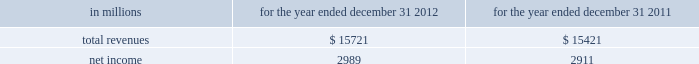See note 10 goodwill and other intangible assets for further discussion of the accounting for goodwill and other intangible assets .
The estimated amount of rbc bank ( usa ) revenue and net income ( excluding integration costs ) included in pnc 2019s consolidated income statement for 2012 was $ 1.0 billion and $ 273 million , respectively .
Upon closing and conversion of the rbc bank ( usa ) transaction , subsequent to march 2 , 2012 , separate records for rbc bank ( usa ) as a stand-alone business have not been maintained as the operations of rbc bank ( usa ) have been fully integrated into pnc .
Rbc bank ( usa ) revenue and earnings disclosed above reflect management 2019s best estimate , based on information available at the reporting date .
The table presents certain unaudited pro forma information for illustrative purposes only , for 2012 and 2011 as if rbc bank ( usa ) had been acquired on january 1 , 2011 .
The unaudited estimated pro forma information combines the historical results of rbc bank ( usa ) with the company 2019s consolidated historical results and includes certain adjustments reflecting the estimated impact of certain fair value adjustments for the respective periods .
The pro forma information is not indicative of what would have occurred had the acquisition taken place on january 1 , 2011 .
In particular , no adjustments have been made to eliminate the impact of other-than-temporary impairment losses and losses recognized on the sale of securities that may not have been necessary had the investment securities been recorded at fair value as of january 1 , 2011 .
The unaudited pro forma information does not consider any changes to the provision for credit losses resulting from recording loan assets at fair value .
Additionally , the pro forma financial information does not include the impact of possible business model changes and does not reflect pro forma adjustments to conform accounting policies between rbc bank ( usa ) and pnc .
Additionally , pnc expects to achieve further operating cost savings and other business synergies , including revenue growth , as a result of the acquisition that are not reflected in the pro forma amounts that follow .
As a result , actual results will differ from the unaudited pro forma information presented .
Table 57 : rbc bank ( usa ) and pnc unaudited pro forma results .
In connection with the rbc bank ( usa ) acquisition and other prior acquisitions , pnc recognized $ 267 million of integration charges in 2012 .
Pnc recognized $ 42 million of integration charges in 2011 in connection with prior acquisitions .
The integration charges are included in the table above .
Sale of smartstreet effective october 26 , 2012 , pnc divested certain deposits and assets of the smartstreet business unit , which was acquired by pnc as part of the rbc bank ( usa ) acquisition , to union bank , n.a .
Smartstreet is a nationwide business focused on homeowner or community association managers and had approximately $ 1 billion of assets and deposits as of september 30 , 2012 .
The gain on sale was immaterial and resulted in a reduction of goodwill and core deposit intangibles of $ 46 million and $ 13 million , respectively .
Results from operations of smartstreet from march 2 , 2012 through october 26 , 2012 are included in our consolidated income statement .
Flagstar branch acquisition effective december 9 , 2011 , pnc acquired 27 branches in the northern metropolitan atlanta , georgia area from flagstar bank , fsb , a subsidiary of flagstar bancorp , inc .
The fair value of the assets acquired totaled approximately $ 211.8 million , including $ 169.3 million in cash , $ 24.3 million in fixed assets and $ 18.2 million of goodwill and intangible assets .
We also assumed approximately $ 210.5 million of deposits associated with these branches .
No deposit premium was paid and no loans were acquired in the transaction .
Our consolidated income statement includes the impact of the branch activity subsequent to our december 9 , 2011 acquisition .
Bankatlantic branch acquisition effective june 6 , 2011 , we acquired 19 branches in the greater tampa , florida area from bankatlantic , a subsidiary of bankatlantic bancorp , inc .
The fair value of the assets acquired totaled $ 324.9 million , including $ 256.9 million in cash , $ 26.0 million in fixed assets and $ 42.0 million of goodwill and intangible assets .
We also assumed approximately $ 324.5 million of deposits associated with these branches .
A $ 39.0 million deposit premium was paid and no loans were acquired in the transaction .
Our consolidated income statement includes the impact of the branch activity subsequent to our june 6 , 2011 acquisition .
Sale of pnc global investment servicing on july 1 , 2010 , we sold pnc global investment servicing inc .
( gis ) , a leading provider of processing , technology and business intelligence services to asset managers , broker- dealers and financial advisors worldwide , for $ 2.3 billion in cash pursuant to a definitive agreement entered into on february 2 , 2010 .
This transaction resulted in a pretax gain of $ 639 million , net of transaction costs , in the third quarter of 2010 .
This gain and results of operations of gis through june 30 , 2010 are presented as income from discontinued operations , net of income taxes , on our consolidated income statement .
As part of the sale agreement , pnc has agreed to provide certain transitional services on behalf of gis until completion of related systems conversion activities .
138 the pnc financial services group , inc .
2013 form 10-k .
What percentage of the total assets acquired from bank atlantic were the fixed assets? 
Computations: (26.0 / 324.9)
Answer: 0.08002. See note 10 goodwill and other intangible assets for further discussion of the accounting for goodwill and other intangible assets .
The estimated amount of rbc bank ( usa ) revenue and net income ( excluding integration costs ) included in pnc 2019s consolidated income statement for 2012 was $ 1.0 billion and $ 273 million , respectively .
Upon closing and conversion of the rbc bank ( usa ) transaction , subsequent to march 2 , 2012 , separate records for rbc bank ( usa ) as a stand-alone business have not been maintained as the operations of rbc bank ( usa ) have been fully integrated into pnc .
Rbc bank ( usa ) revenue and earnings disclosed above reflect management 2019s best estimate , based on information available at the reporting date .
The table presents certain unaudited pro forma information for illustrative purposes only , for 2012 and 2011 as if rbc bank ( usa ) had been acquired on january 1 , 2011 .
The unaudited estimated pro forma information combines the historical results of rbc bank ( usa ) with the company 2019s consolidated historical results and includes certain adjustments reflecting the estimated impact of certain fair value adjustments for the respective periods .
The pro forma information is not indicative of what would have occurred had the acquisition taken place on january 1 , 2011 .
In particular , no adjustments have been made to eliminate the impact of other-than-temporary impairment losses and losses recognized on the sale of securities that may not have been necessary had the investment securities been recorded at fair value as of january 1 , 2011 .
The unaudited pro forma information does not consider any changes to the provision for credit losses resulting from recording loan assets at fair value .
Additionally , the pro forma financial information does not include the impact of possible business model changes and does not reflect pro forma adjustments to conform accounting policies between rbc bank ( usa ) and pnc .
Additionally , pnc expects to achieve further operating cost savings and other business synergies , including revenue growth , as a result of the acquisition that are not reflected in the pro forma amounts that follow .
As a result , actual results will differ from the unaudited pro forma information presented .
Table 57 : rbc bank ( usa ) and pnc unaudited pro forma results .
In connection with the rbc bank ( usa ) acquisition and other prior acquisitions , pnc recognized $ 267 million of integration charges in 2012 .
Pnc recognized $ 42 million of integration charges in 2011 in connection with prior acquisitions .
The integration charges are included in the table above .
Sale of smartstreet effective october 26 , 2012 , pnc divested certain deposits and assets of the smartstreet business unit , which was acquired by pnc as part of the rbc bank ( usa ) acquisition , to union bank , n.a .
Smartstreet is a nationwide business focused on homeowner or community association managers and had approximately $ 1 billion of assets and deposits as of september 30 , 2012 .
The gain on sale was immaterial and resulted in a reduction of goodwill and core deposit intangibles of $ 46 million and $ 13 million , respectively .
Results from operations of smartstreet from march 2 , 2012 through october 26 , 2012 are included in our consolidated income statement .
Flagstar branch acquisition effective december 9 , 2011 , pnc acquired 27 branches in the northern metropolitan atlanta , georgia area from flagstar bank , fsb , a subsidiary of flagstar bancorp , inc .
The fair value of the assets acquired totaled approximately $ 211.8 million , including $ 169.3 million in cash , $ 24.3 million in fixed assets and $ 18.2 million of goodwill and intangible assets .
We also assumed approximately $ 210.5 million of deposits associated with these branches .
No deposit premium was paid and no loans were acquired in the transaction .
Our consolidated income statement includes the impact of the branch activity subsequent to our december 9 , 2011 acquisition .
Bankatlantic branch acquisition effective june 6 , 2011 , we acquired 19 branches in the greater tampa , florida area from bankatlantic , a subsidiary of bankatlantic bancorp , inc .
The fair value of the assets acquired totaled $ 324.9 million , including $ 256.9 million in cash , $ 26.0 million in fixed assets and $ 42.0 million of goodwill and intangible assets .
We also assumed approximately $ 324.5 million of deposits associated with these branches .
A $ 39.0 million deposit premium was paid and no loans were acquired in the transaction .
Our consolidated income statement includes the impact of the branch activity subsequent to our june 6 , 2011 acquisition .
Sale of pnc global investment servicing on july 1 , 2010 , we sold pnc global investment servicing inc .
( gis ) , a leading provider of processing , technology and business intelligence services to asset managers , broker- dealers and financial advisors worldwide , for $ 2.3 billion in cash pursuant to a definitive agreement entered into on february 2 , 2010 .
This transaction resulted in a pretax gain of $ 639 million , net of transaction costs , in the third quarter of 2010 .
This gain and results of operations of gis through june 30 , 2010 are presented as income from discontinued operations , net of income taxes , on our consolidated income statement .
As part of the sale agreement , pnc has agreed to provide certain transitional services on behalf of gis until completion of related systems conversion activities .
138 the pnc financial services group , inc .
2013 form 10-k .
What was the percent of the cash in the fair value of the assets acquired? 
Computations: (256.9 / 324.9)
Answer: 0.7907. See note 10 goodwill and other intangible assets for further discussion of the accounting for goodwill and other intangible assets .
The estimated amount of rbc bank ( usa ) revenue and net income ( excluding integration costs ) included in pnc 2019s consolidated income statement for 2012 was $ 1.0 billion and $ 273 million , respectively .
Upon closing and conversion of the rbc bank ( usa ) transaction , subsequent to march 2 , 2012 , separate records for rbc bank ( usa ) as a stand-alone business have not been maintained as the operations of rbc bank ( usa ) have been fully integrated into pnc .
Rbc bank ( usa ) revenue and earnings disclosed above reflect management 2019s best estimate , based on information available at the reporting date .
The table presents certain unaudited pro forma information for illustrative purposes only , for 2012 and 2011 as if rbc bank ( usa ) had been acquired on january 1 , 2011 .
The unaudited estimated pro forma information combines the historical results of rbc bank ( usa ) with the company 2019s consolidated historical results and includes certain adjustments reflecting the estimated impact of certain fair value adjustments for the respective periods .
The pro forma information is not indicative of what would have occurred had the acquisition taken place on january 1 , 2011 .
In particular , no adjustments have been made to eliminate the impact of other-than-temporary impairment losses and losses recognized on the sale of securities that may not have been necessary had the investment securities been recorded at fair value as of january 1 , 2011 .
The unaudited pro forma information does not consider any changes to the provision for credit losses resulting from recording loan assets at fair value .
Additionally , the pro forma financial information does not include the impact of possible business model changes and does not reflect pro forma adjustments to conform accounting policies between rbc bank ( usa ) and pnc .
Additionally , pnc expects to achieve further operating cost savings and other business synergies , including revenue growth , as a result of the acquisition that are not reflected in the pro forma amounts that follow .
As a result , actual results will differ from the unaudited pro forma information presented .
Table 57 : rbc bank ( usa ) and pnc unaudited pro forma results .
In connection with the rbc bank ( usa ) acquisition and other prior acquisitions , pnc recognized $ 267 million of integration charges in 2012 .
Pnc recognized $ 42 million of integration charges in 2011 in connection with prior acquisitions .
The integration charges are included in the table above .
Sale of smartstreet effective october 26 , 2012 , pnc divested certain deposits and assets of the smartstreet business unit , which was acquired by pnc as part of the rbc bank ( usa ) acquisition , to union bank , n.a .
Smartstreet is a nationwide business focused on homeowner or community association managers and had approximately $ 1 billion of assets and deposits as of september 30 , 2012 .
The gain on sale was immaterial and resulted in a reduction of goodwill and core deposit intangibles of $ 46 million and $ 13 million , respectively .
Results from operations of smartstreet from march 2 , 2012 through october 26 , 2012 are included in our consolidated income statement .
Flagstar branch acquisition effective december 9 , 2011 , pnc acquired 27 branches in the northern metropolitan atlanta , georgia area from flagstar bank , fsb , a subsidiary of flagstar bancorp , inc .
The fair value of the assets acquired totaled approximately $ 211.8 million , including $ 169.3 million in cash , $ 24.3 million in fixed assets and $ 18.2 million of goodwill and intangible assets .
We also assumed approximately $ 210.5 million of deposits associated with these branches .
No deposit premium was paid and no loans were acquired in the transaction .
Our consolidated income statement includes the impact of the branch activity subsequent to our december 9 , 2011 acquisition .
Bankatlantic branch acquisition effective june 6 , 2011 , we acquired 19 branches in the greater tampa , florida area from bankatlantic , a subsidiary of bankatlantic bancorp , inc .
The fair value of the assets acquired totaled $ 324.9 million , including $ 256.9 million in cash , $ 26.0 million in fixed assets and $ 42.0 million of goodwill and intangible assets .
We also assumed approximately $ 324.5 million of deposits associated with these branches .
A $ 39.0 million deposit premium was paid and no loans were acquired in the transaction .
Our consolidated income statement includes the impact of the branch activity subsequent to our june 6 , 2011 acquisition .
Sale of pnc global investment servicing on july 1 , 2010 , we sold pnc global investment servicing inc .
( gis ) , a leading provider of processing , technology and business intelligence services to asset managers , broker- dealers and financial advisors worldwide , for $ 2.3 billion in cash pursuant to a definitive agreement entered into on february 2 , 2010 .
This transaction resulted in a pretax gain of $ 639 million , net of transaction costs , in the third quarter of 2010 .
This gain and results of operations of gis through june 30 , 2010 are presented as income from discontinued operations , net of income taxes , on our consolidated income statement .
As part of the sale agreement , pnc has agreed to provide certain transitional services on behalf of gis until completion of related systems conversion activities .
138 the pnc financial services group , inc .
2013 form 10-k .
Excluding recognized in 2011 in connection with prior acquisitions , what would net income be in millions? 
Computations: (2911 + 42.0)
Answer: 2953.0. 